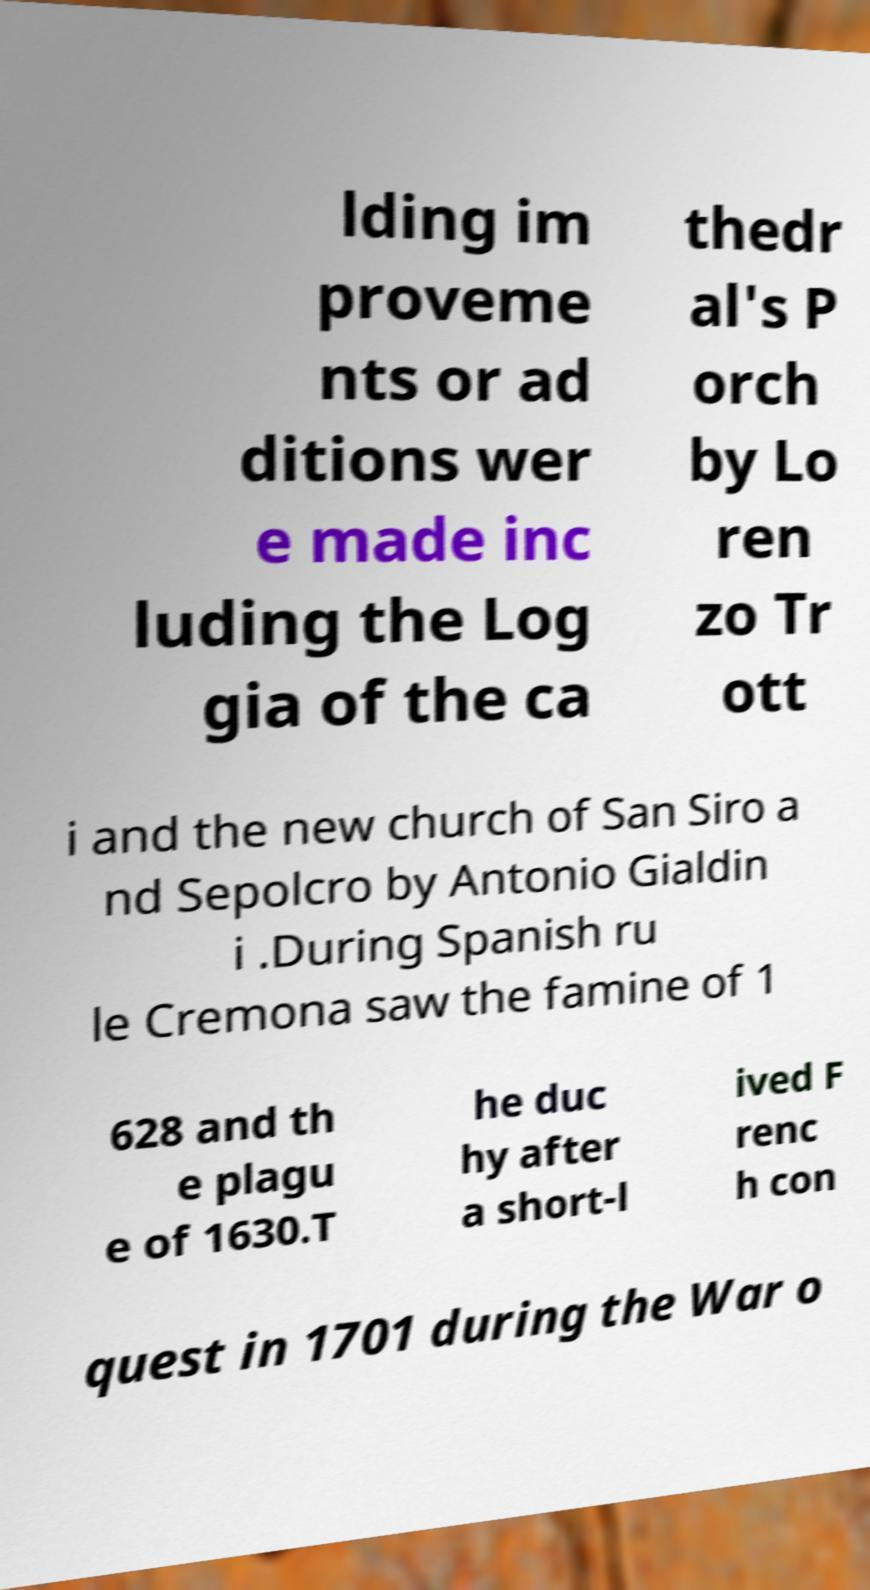Can you read and provide the text displayed in the image?This photo seems to have some interesting text. Can you extract and type it out for me? lding im proveme nts or ad ditions wer e made inc luding the Log gia of the ca thedr al's P orch by Lo ren zo Tr ott i and the new church of San Siro a nd Sepolcro by Antonio Gialdin i .During Spanish ru le Cremona saw the famine of 1 628 and th e plagu e of 1630.T he duc hy after a short-l ived F renc h con quest in 1701 during the War o 